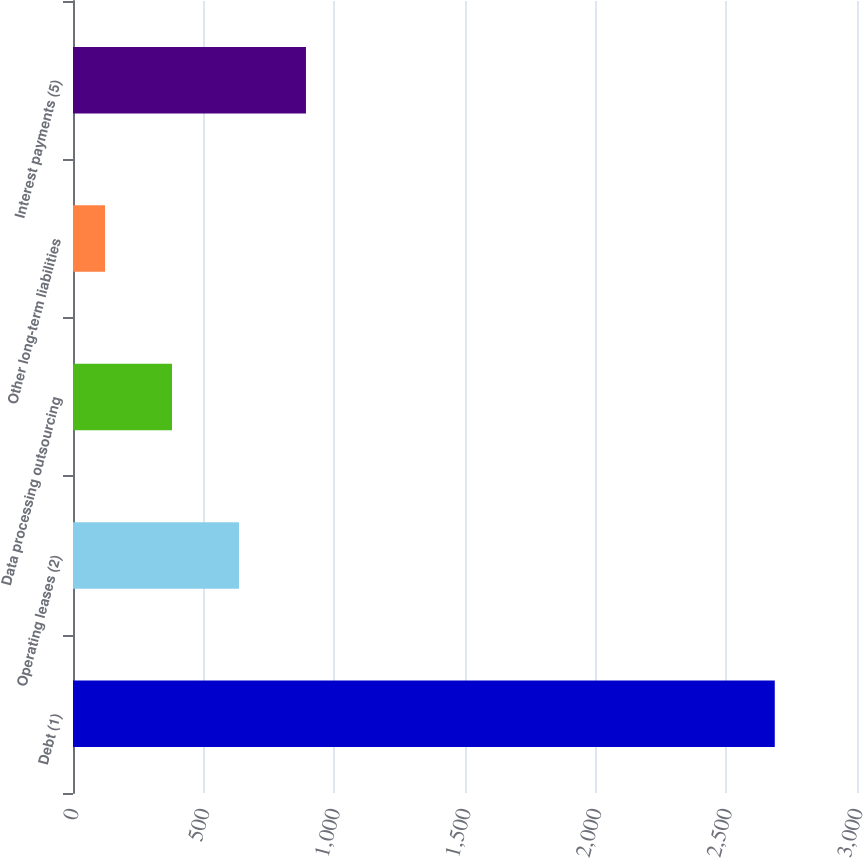Convert chart. <chart><loc_0><loc_0><loc_500><loc_500><bar_chart><fcel>Debt (1)<fcel>Operating leases (2)<fcel>Data processing outsourcing<fcel>Other long-term liabilities<fcel>Interest payments (5)<nl><fcel>2685.4<fcel>635.16<fcel>378.88<fcel>122.6<fcel>891.44<nl></chart> 